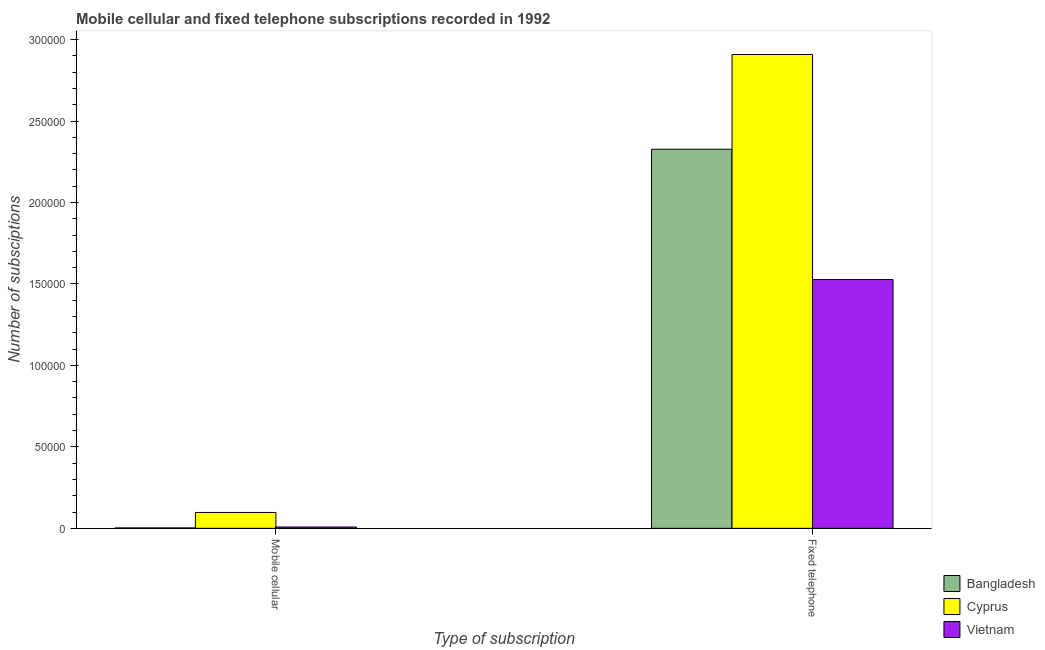How many different coloured bars are there?
Offer a terse response. 3. Are the number of bars per tick equal to the number of legend labels?
Your response must be concise. Yes. How many bars are there on the 2nd tick from the left?
Your response must be concise. 3. How many bars are there on the 2nd tick from the right?
Ensure brevity in your answer.  3. What is the label of the 1st group of bars from the left?
Provide a short and direct response. Mobile cellular. What is the number of fixed telephone subscriptions in Cyprus?
Your response must be concise. 2.91e+05. Across all countries, what is the maximum number of mobile cellular subscriptions?
Provide a succinct answer. 9739. Across all countries, what is the minimum number of fixed telephone subscriptions?
Give a very brief answer. 1.53e+05. In which country was the number of fixed telephone subscriptions maximum?
Your answer should be compact. Cyprus. In which country was the number of mobile cellular subscriptions minimum?
Ensure brevity in your answer.  Bangladesh. What is the total number of fixed telephone subscriptions in the graph?
Make the answer very short. 6.76e+05. What is the difference between the number of mobile cellular subscriptions in Bangladesh and that in Vietnam?
Offer a terse response. -550. What is the difference between the number of fixed telephone subscriptions in Cyprus and the number of mobile cellular subscriptions in Bangladesh?
Your response must be concise. 2.91e+05. What is the average number of mobile cellular subscriptions per country?
Provide a succinct answer. 3596.33. What is the difference between the number of fixed telephone subscriptions and number of mobile cellular subscriptions in Vietnam?
Your answer should be very brief. 1.52e+05. In how many countries, is the number of fixed telephone subscriptions greater than 260000 ?
Provide a short and direct response. 1. What is the ratio of the number of mobile cellular subscriptions in Cyprus to that in Bangladesh?
Provide a short and direct response. 38.96. Is the number of fixed telephone subscriptions in Cyprus less than that in Bangladesh?
Give a very brief answer. No. In how many countries, is the number of mobile cellular subscriptions greater than the average number of mobile cellular subscriptions taken over all countries?
Offer a very short reply. 1. What does the 2nd bar from the right in Mobile cellular represents?
Give a very brief answer. Cyprus. How many bars are there?
Keep it short and to the point. 6. How many countries are there in the graph?
Give a very brief answer. 3. What is the difference between two consecutive major ticks on the Y-axis?
Offer a terse response. 5.00e+04. Are the values on the major ticks of Y-axis written in scientific E-notation?
Offer a very short reply. No. Does the graph contain any zero values?
Your answer should be compact. No. Does the graph contain grids?
Make the answer very short. No. How are the legend labels stacked?
Make the answer very short. Vertical. What is the title of the graph?
Provide a short and direct response. Mobile cellular and fixed telephone subscriptions recorded in 1992. What is the label or title of the X-axis?
Your answer should be compact. Type of subscription. What is the label or title of the Y-axis?
Provide a short and direct response. Number of subsciptions. What is the Number of subsciptions in Bangladesh in Mobile cellular?
Your response must be concise. 250. What is the Number of subsciptions in Cyprus in Mobile cellular?
Your response must be concise. 9739. What is the Number of subsciptions in Vietnam in Mobile cellular?
Offer a very short reply. 800. What is the Number of subsciptions in Bangladesh in Fixed telephone?
Ensure brevity in your answer.  2.33e+05. What is the Number of subsciptions of Cyprus in Fixed telephone?
Provide a short and direct response. 2.91e+05. What is the Number of subsciptions of Vietnam in Fixed telephone?
Provide a succinct answer. 1.53e+05. Across all Type of subscription, what is the maximum Number of subsciptions of Bangladesh?
Provide a succinct answer. 2.33e+05. Across all Type of subscription, what is the maximum Number of subsciptions of Cyprus?
Offer a very short reply. 2.91e+05. Across all Type of subscription, what is the maximum Number of subsciptions of Vietnam?
Make the answer very short. 1.53e+05. Across all Type of subscription, what is the minimum Number of subsciptions of Bangladesh?
Ensure brevity in your answer.  250. Across all Type of subscription, what is the minimum Number of subsciptions in Cyprus?
Your response must be concise. 9739. Across all Type of subscription, what is the minimum Number of subsciptions of Vietnam?
Keep it short and to the point. 800. What is the total Number of subsciptions of Bangladesh in the graph?
Offer a very short reply. 2.33e+05. What is the total Number of subsciptions of Cyprus in the graph?
Offer a very short reply. 3.01e+05. What is the total Number of subsciptions in Vietnam in the graph?
Ensure brevity in your answer.  1.54e+05. What is the difference between the Number of subsciptions of Bangladesh in Mobile cellular and that in Fixed telephone?
Provide a succinct answer. -2.32e+05. What is the difference between the Number of subsciptions in Cyprus in Mobile cellular and that in Fixed telephone?
Keep it short and to the point. -2.81e+05. What is the difference between the Number of subsciptions in Vietnam in Mobile cellular and that in Fixed telephone?
Offer a terse response. -1.52e+05. What is the difference between the Number of subsciptions in Bangladesh in Mobile cellular and the Number of subsciptions in Cyprus in Fixed telephone?
Make the answer very short. -2.91e+05. What is the difference between the Number of subsciptions of Bangladesh in Mobile cellular and the Number of subsciptions of Vietnam in Fixed telephone?
Give a very brief answer. -1.52e+05. What is the difference between the Number of subsciptions of Cyprus in Mobile cellular and the Number of subsciptions of Vietnam in Fixed telephone?
Offer a very short reply. -1.43e+05. What is the average Number of subsciptions in Bangladesh per Type of subscription?
Keep it short and to the point. 1.16e+05. What is the average Number of subsciptions in Cyprus per Type of subscription?
Your answer should be compact. 1.50e+05. What is the average Number of subsciptions in Vietnam per Type of subscription?
Offer a very short reply. 7.68e+04. What is the difference between the Number of subsciptions in Bangladesh and Number of subsciptions in Cyprus in Mobile cellular?
Keep it short and to the point. -9489. What is the difference between the Number of subsciptions in Bangladesh and Number of subsciptions in Vietnam in Mobile cellular?
Your answer should be very brief. -550. What is the difference between the Number of subsciptions in Cyprus and Number of subsciptions in Vietnam in Mobile cellular?
Give a very brief answer. 8939. What is the difference between the Number of subsciptions in Bangladesh and Number of subsciptions in Cyprus in Fixed telephone?
Your answer should be very brief. -5.82e+04. What is the difference between the Number of subsciptions of Bangladesh and Number of subsciptions of Vietnam in Fixed telephone?
Provide a succinct answer. 8.00e+04. What is the difference between the Number of subsciptions of Cyprus and Number of subsciptions of Vietnam in Fixed telephone?
Keep it short and to the point. 1.38e+05. What is the ratio of the Number of subsciptions in Bangladesh in Mobile cellular to that in Fixed telephone?
Offer a terse response. 0. What is the ratio of the Number of subsciptions of Cyprus in Mobile cellular to that in Fixed telephone?
Provide a succinct answer. 0.03. What is the ratio of the Number of subsciptions of Vietnam in Mobile cellular to that in Fixed telephone?
Your answer should be compact. 0.01. What is the difference between the highest and the second highest Number of subsciptions in Bangladesh?
Make the answer very short. 2.32e+05. What is the difference between the highest and the second highest Number of subsciptions of Cyprus?
Offer a very short reply. 2.81e+05. What is the difference between the highest and the second highest Number of subsciptions of Vietnam?
Offer a terse response. 1.52e+05. What is the difference between the highest and the lowest Number of subsciptions of Bangladesh?
Provide a short and direct response. 2.32e+05. What is the difference between the highest and the lowest Number of subsciptions in Cyprus?
Your answer should be very brief. 2.81e+05. What is the difference between the highest and the lowest Number of subsciptions in Vietnam?
Offer a terse response. 1.52e+05. 